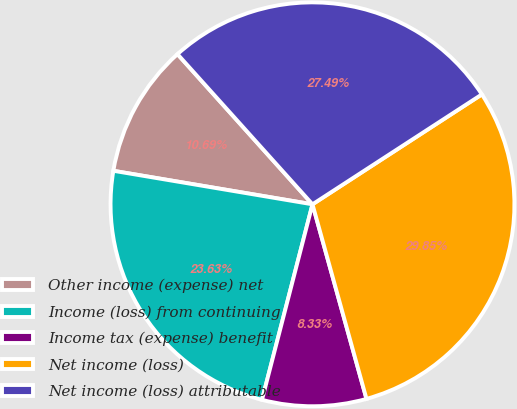Convert chart. <chart><loc_0><loc_0><loc_500><loc_500><pie_chart><fcel>Other income (expense) net<fcel>Income (loss) from continuing<fcel>Income tax (expense) benefit<fcel>Net income (loss)<fcel>Net income (loss) attributable<nl><fcel>10.69%<fcel>23.63%<fcel>8.33%<fcel>29.85%<fcel>27.49%<nl></chart> 